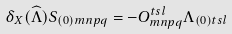Convert formula to latex. <formula><loc_0><loc_0><loc_500><loc_500>\delta _ { X } ( \widehat { \Lambda } ) S _ { ( 0 ) m n p q } = - O _ { m n p q } ^ { t s l } \Lambda _ { ( 0 ) t s l }</formula> 